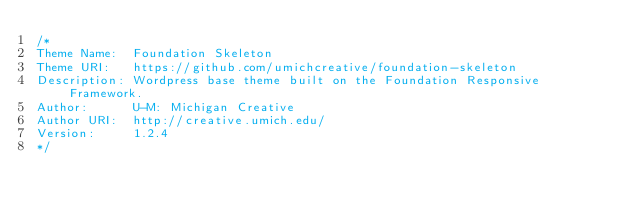<code> <loc_0><loc_0><loc_500><loc_500><_CSS_>/*
Theme Name:  Foundation Skeleton
Theme URI:   https://github.com/umichcreative/foundation-skeleton
Description: Wordpress base theme built on the Foundation Responsive Framework.
Author:      U-M: Michigan Creative
Author URI:  http://creative.umich.edu/
Version:     1.2.4
*/
</code> 